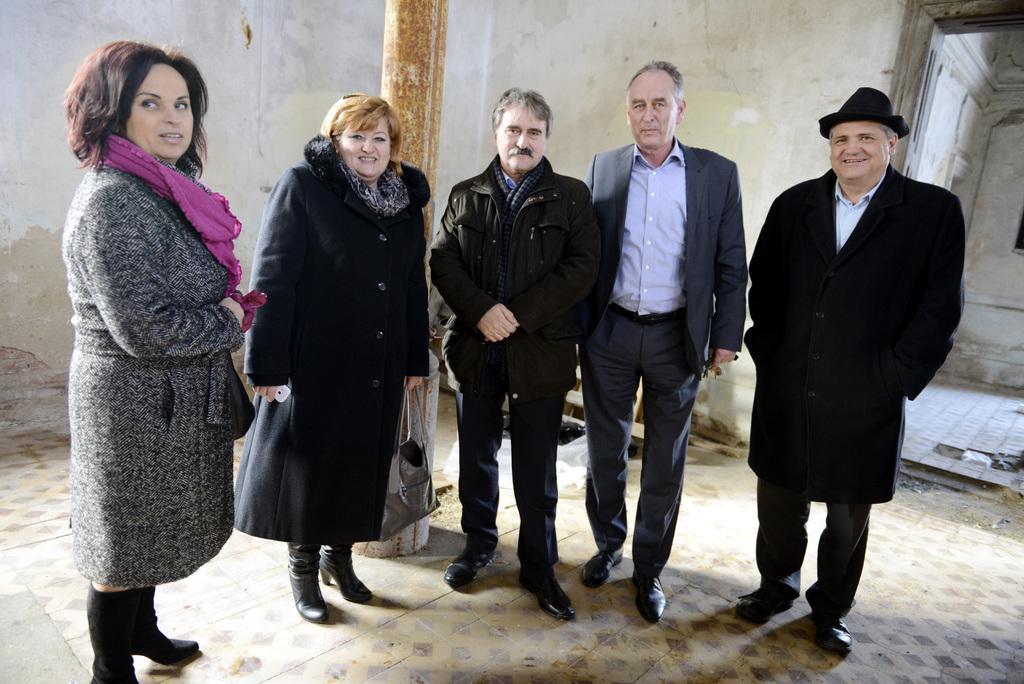How would you summarize this image in a sentence or two? Here I can see two women and three men are standing on the floor, smiling and giving pose for the picture. At the back of these people there is a pillar. In the background there is a wall. One woman is holding a mobile and a bag in the hands. 